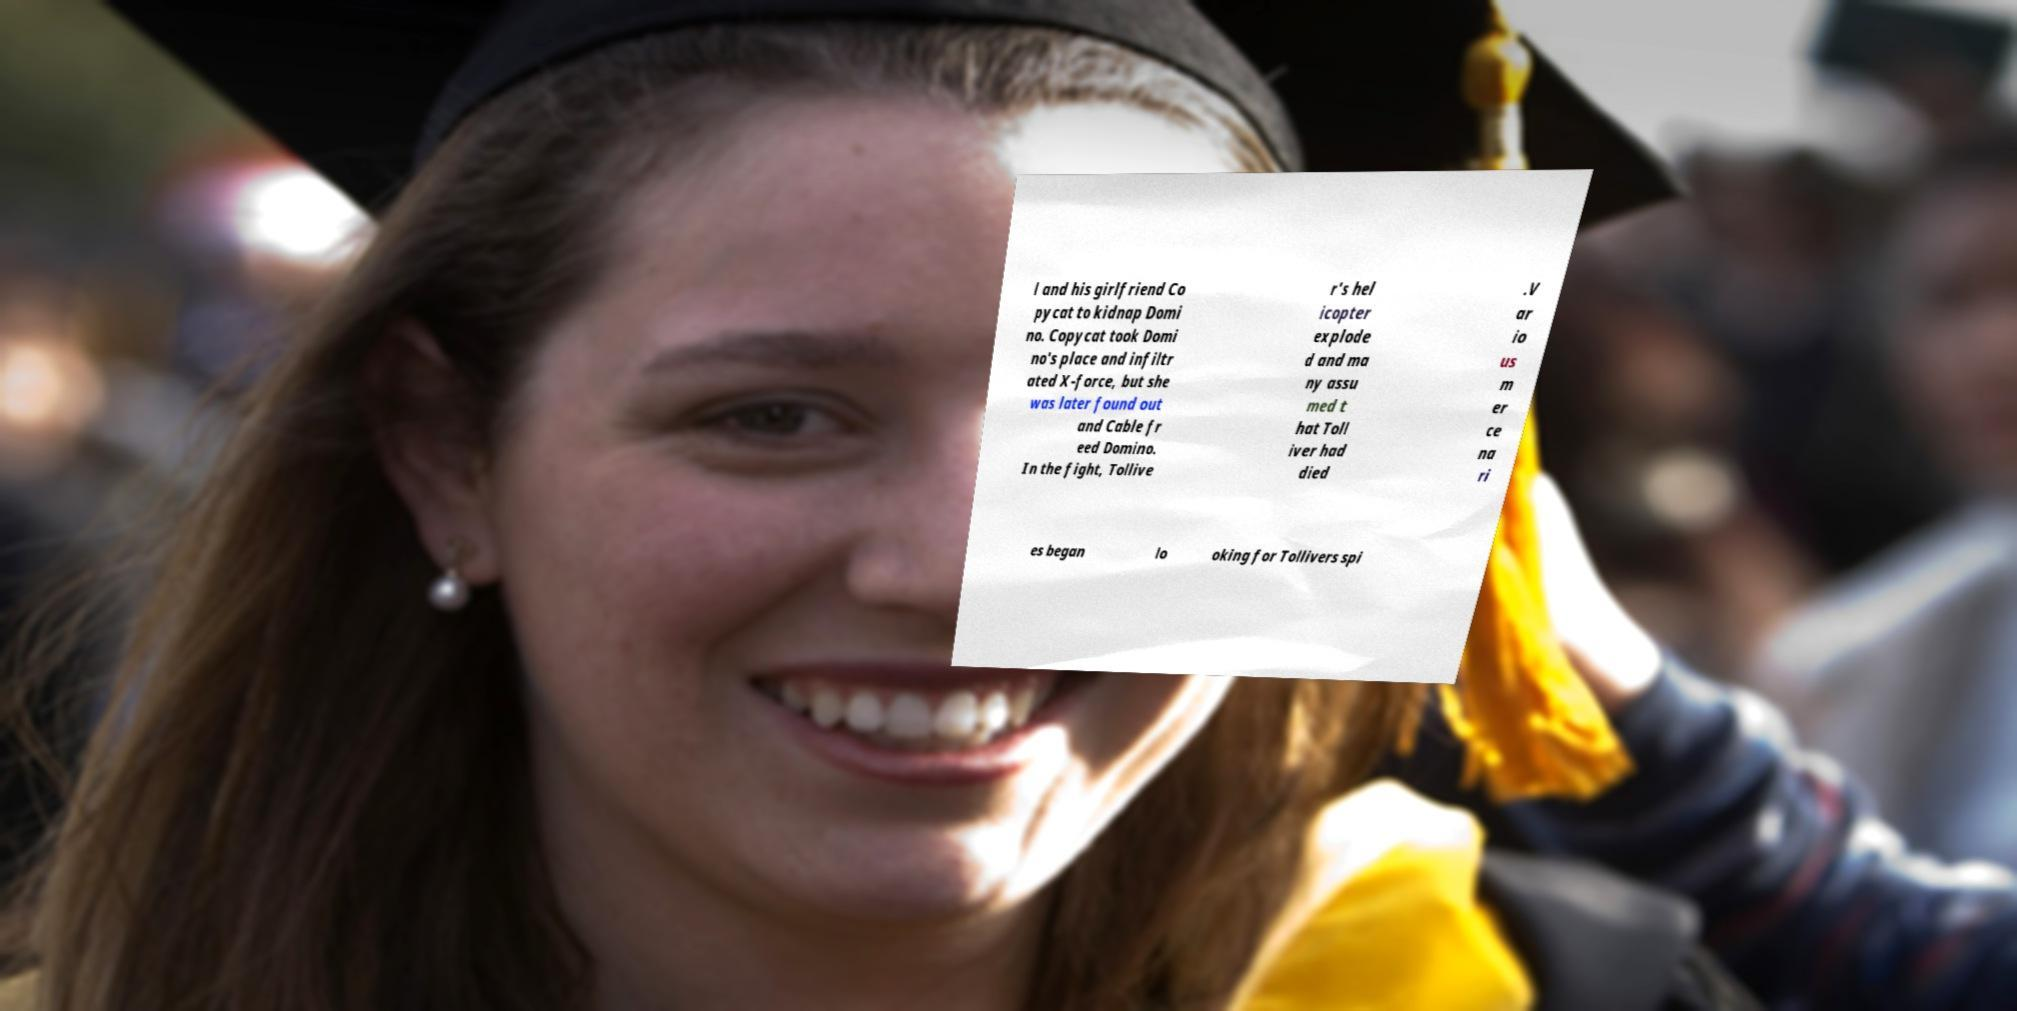Please read and relay the text visible in this image. What does it say? l and his girlfriend Co pycat to kidnap Domi no. Copycat took Domi no's place and infiltr ated X-force, but she was later found out and Cable fr eed Domino. In the fight, Tollive r's hel icopter explode d and ma ny assu med t hat Toll iver had died .V ar io us m er ce na ri es began lo oking for Tollivers spi 